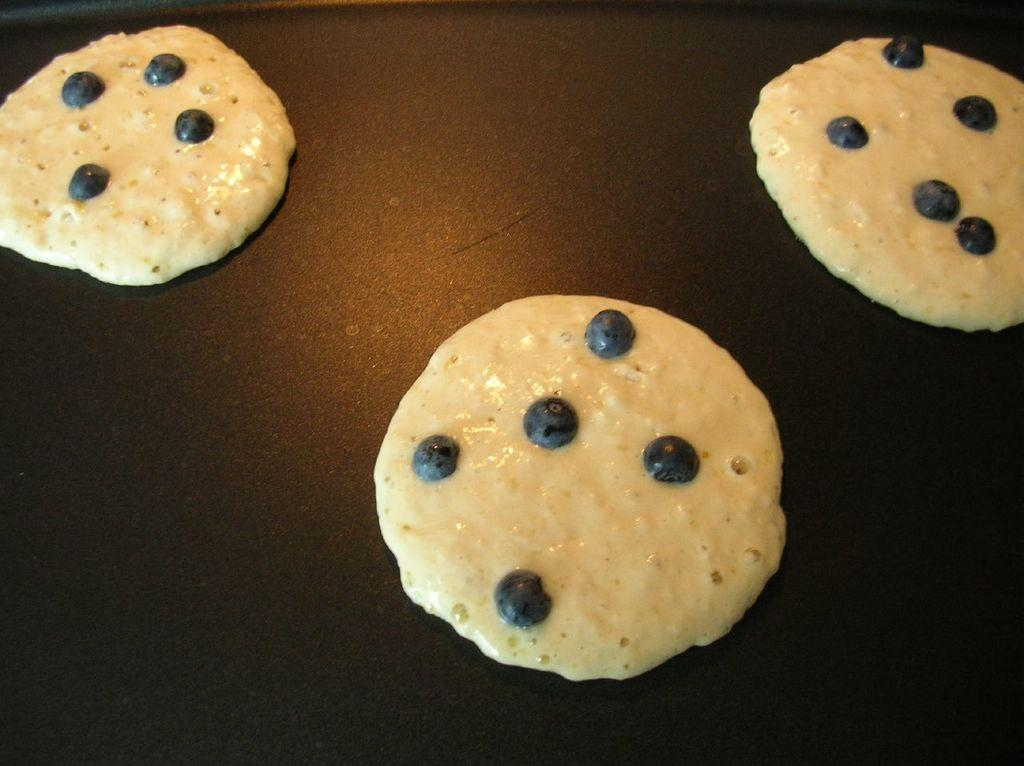How many cookies are visible in the image? There are three cookies in the image. What is the cookies placed on or in? The cookies are in a brown color tray. What type of unit is used to measure the size of the cookies in the image? There is no information provided about measuring the size of the cookies, and no unit is visible in the image. 